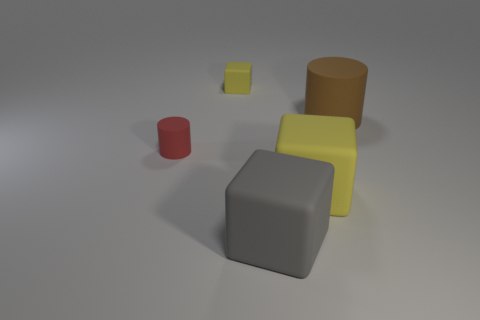Can you describe the arrangement of objects in terms of their colors? Certainly! There are several objects with different colors. In the center, there's a large grey cube. To its right, there's a small yellow cube and behind the yellow cube is a large brown cylinder. To the left of the grey cube, there is a small red cylinder. What can you tell me about the lighting in this scene? The lighting in this scene is soft and diffused, with gentle shadows cast by the objects. There aren't any harsh shadows, suggesting that the light source is not overly strong or it might be evenly distributed above the scene. 